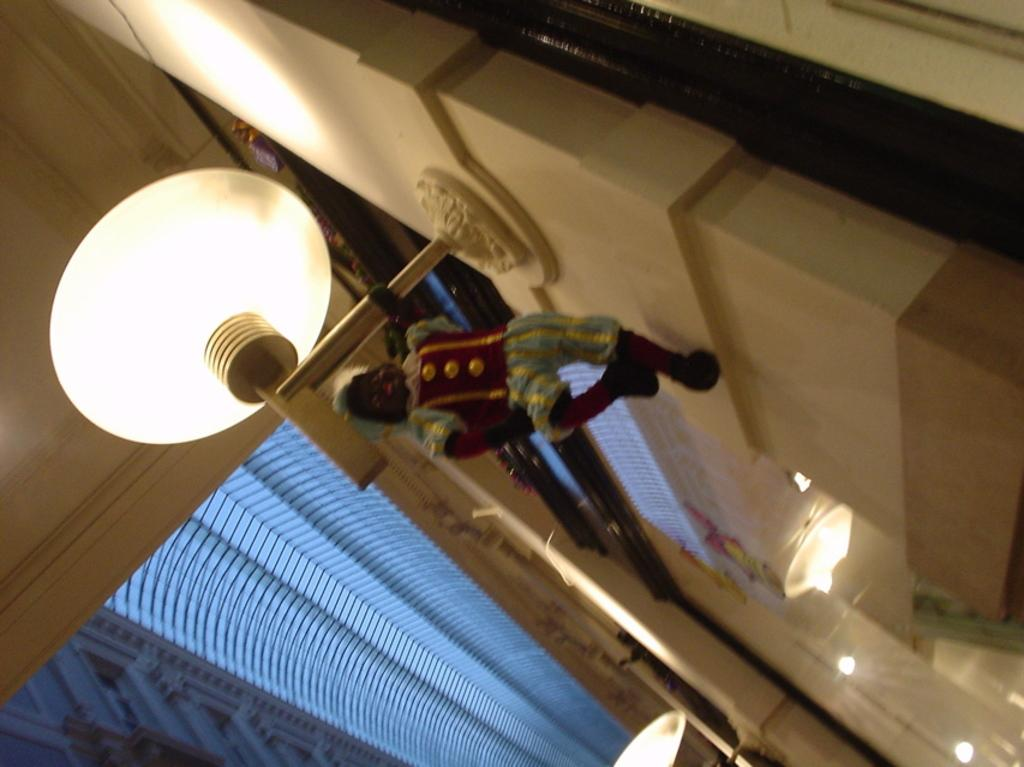What is hanging on the rod in the image? There is a doll hanging on a rod in the image. What can be seen in the image besides the doll? There is a light and a wall visible in the image. What is visible in the background of the image? In the background, there are lights, windows, and a roof top visible. What type of beef is being cooked in the image? There is no beef present in the image; it features a doll hanging on a rod, a light, and a wall. Which actor is performing in the image? There is no actor present in the image; it is a still image featuring a doll, a light, and a wall. 